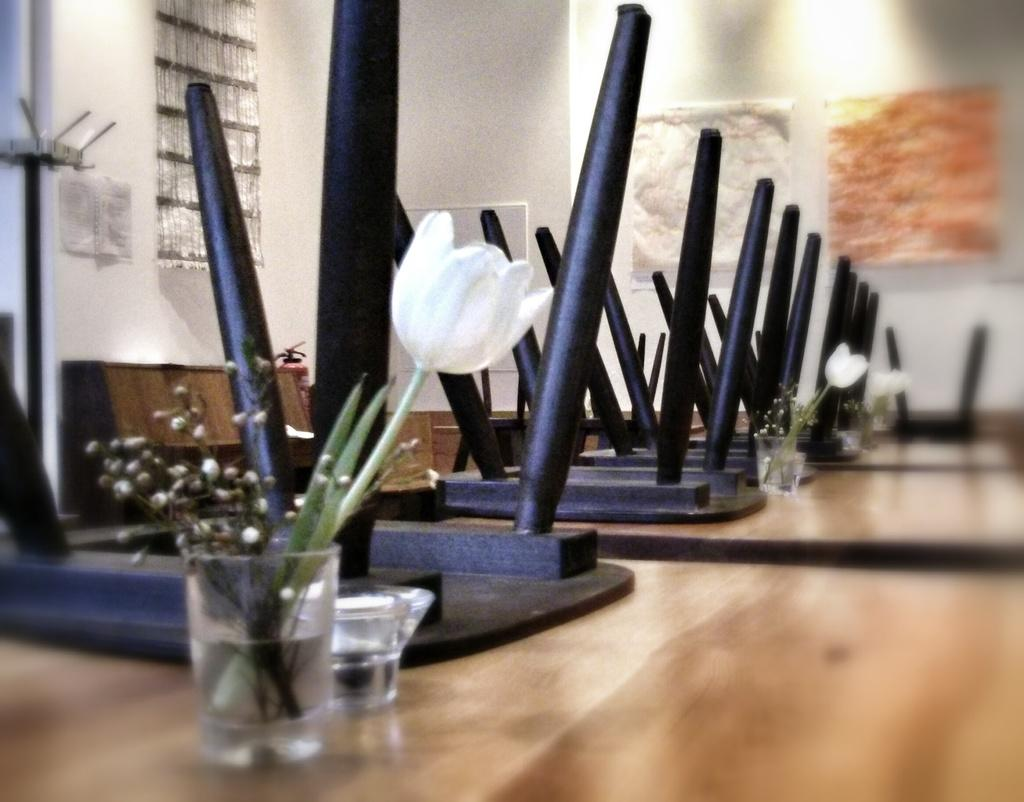What type of furniture is present in the image? There are wooden tables in the image. What is placed on the tables? There are glasses with flowers on the tables. Are there any chairs in the image? Yes, there are chairs on the tables. What can be seen in the background of the image? There is a wall visible in the background of the image. How many cacti are present on the tables in the image? There are no cacti present on the tables in the image; there are glasses with flowers instead. 